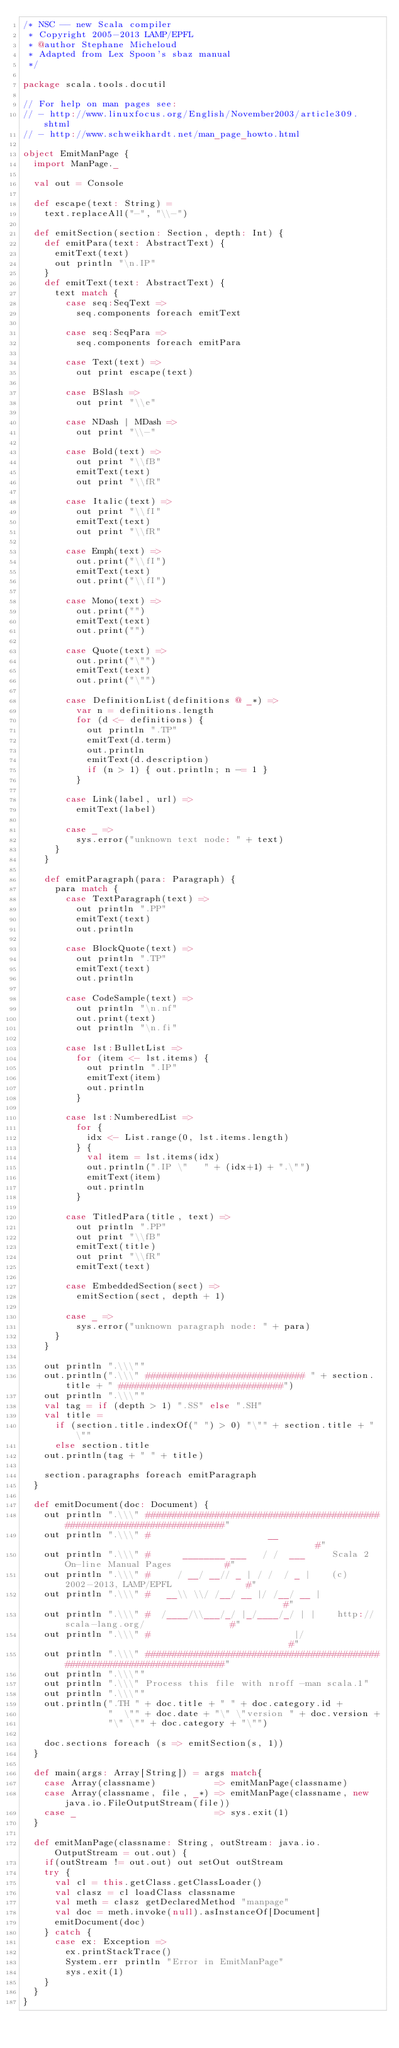Convert code to text. <code><loc_0><loc_0><loc_500><loc_500><_Scala_>/* NSC -- new Scala compiler
 * Copyright 2005-2013 LAMP/EPFL
 * @author Stephane Micheloud
 * Adapted from Lex Spoon's sbaz manual
 */

package scala.tools.docutil

// For help on man pages see:
// - http://www.linuxfocus.org/English/November2003/article309.shtml
// - http://www.schweikhardt.net/man_page_howto.html

object EmitManPage {
  import ManPage._

  val out = Console

  def escape(text: String) =
    text.replaceAll("-", "\\-")

  def emitSection(section: Section, depth: Int) {
    def emitPara(text: AbstractText) {
      emitText(text)
      out println "\n.IP"
    }
    def emitText(text: AbstractText) {
      text match {
        case seq:SeqText =>
          seq.components foreach emitText

        case seq:SeqPara =>
          seq.components foreach emitPara

        case Text(text) =>
          out print escape(text)

        case BSlash =>
          out print "\\e"

        case NDash | MDash =>
          out print "\\-"

        case Bold(text) =>
          out print "\\fB"
          emitText(text)
          out print "\\fR"

        case Italic(text) =>
          out print "\\fI"
          emitText(text)
          out print "\\fR"

        case Emph(text) =>
          out.print("\\fI")
          emitText(text)
          out.print("\\fI")

        case Mono(text) =>
          out.print("")
          emitText(text)
          out.print("")

        case Quote(text) =>
          out.print("\"")
          emitText(text)
          out.print("\"")

        case DefinitionList(definitions @ _*) =>
          var n = definitions.length
          for (d <- definitions) {
            out println ".TP"
            emitText(d.term)
            out.println
            emitText(d.description)
            if (n > 1) { out.println; n -= 1 }
          }

        case Link(label, url) =>
          emitText(label)

        case _ =>
          sys.error("unknown text node: " + text)
      }
    }

    def emitParagraph(para: Paragraph) {
      para match {
        case TextParagraph(text) =>
          out println ".PP"
          emitText(text)
          out.println

        case BlockQuote(text) =>
          out println ".TP"
          emitText(text)
          out.println

        case CodeSample(text) =>
          out println "\n.nf"
          out.print(text)
          out println "\n.fi"

        case lst:BulletList =>
          for (item <- lst.items) {
            out println ".IP"
            emitText(item)
            out.println
          }

        case lst:NumberedList =>
          for {
            idx <- List.range(0, lst.items.length)
          } {
            val item = lst.items(idx)
            out.println(".IP \"   " + (idx+1) + ".\"")
            emitText(item)
            out.println
          }

        case TitledPara(title, text) =>
          out println ".PP"
          out print "\\fB"
          emitText(title)
          out print "\\fR"
          emitText(text)

        case EmbeddedSection(sect) =>
          emitSection(sect, depth + 1)

        case _ =>
          sys.error("unknown paragraph node: " + para)
      }
    }

    out println ".\\\""
    out.println(".\\\" ############################## " + section.title + " ###############################")
    out println ".\\\""
    val tag = if (depth > 1) ".SS" else ".SH"
    val title =
      if (section.title.indexOf(" ") > 0) "\"" + section.title + "\""
      else section.title
    out.println(tag + " " + title)

    section.paragraphs foreach emitParagraph
  }

  def emitDocument(doc: Document) {
    out println ".\\\" ##########################################################################"
    out println ".\\\" #                      __                                                #"
    out println ".\\\" #      ________ ___   / /  ___     Scala 2 On-line Manual Pages          #"
    out println ".\\\" #     / __/ __// _ | / /  / _ |    (c) 2002-2013, LAMP/EPFL              #"
    out println ".\\\" #   __\\ \\/ /__/ __ |/ /__/ __ |                                          #"
    out println ".\\\" #  /____/\\___/_/ |_/____/_/ | |    http://scala-lang.org/                #"
    out println ".\\\" #                           |/                                           #"
    out println ".\\\" ##########################################################################"
    out println ".\\\""
    out println ".\\\" Process this file with nroff -man scala.1"
    out println ".\\\""
    out.println(".TH " + doc.title + " " + doc.category.id +
                "  \"" + doc.date + "\" \"version " + doc.version +
                "\" \"" + doc.category + "\"")

    doc.sections foreach (s => emitSection(s, 1))
  }

  def main(args: Array[String]) = args match{
    case Array(classname)           => emitManPage(classname)
    case Array(classname, file, _*) => emitManPage(classname, new java.io.FileOutputStream(file))
    case _                          => sys.exit(1)
  }

  def emitManPage(classname: String, outStream: java.io.OutputStream = out.out) {
    if(outStream != out.out) out setOut outStream
    try {
      val cl = this.getClass.getClassLoader()
      val clasz = cl loadClass classname
      val meth = clasz getDeclaredMethod "manpage"
      val doc = meth.invoke(null).asInstanceOf[Document]
      emitDocument(doc)
    } catch {
      case ex: Exception =>
        ex.printStackTrace()
        System.err println "Error in EmitManPage"
        sys.exit(1)
    }
  }
}
</code> 